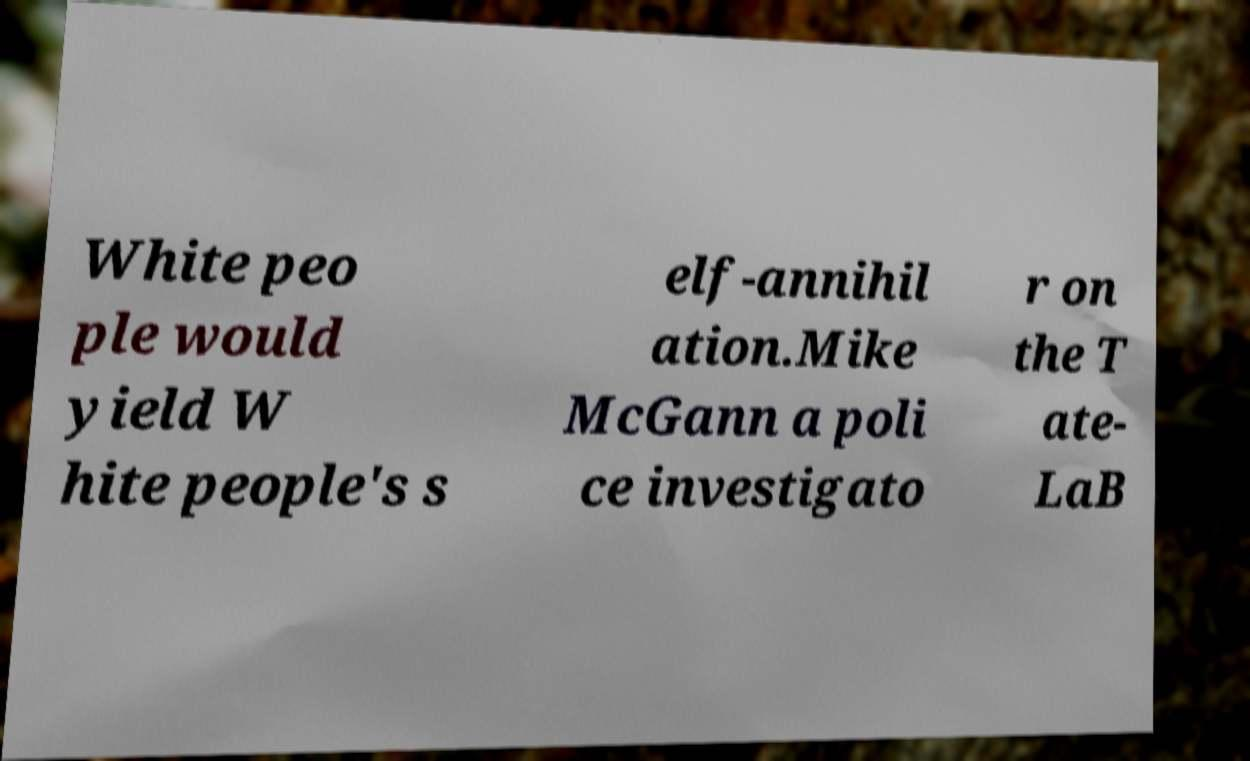Please read and relay the text visible in this image. What does it say? White peo ple would yield W hite people's s elf-annihil ation.Mike McGann a poli ce investigato r on the T ate- LaB 